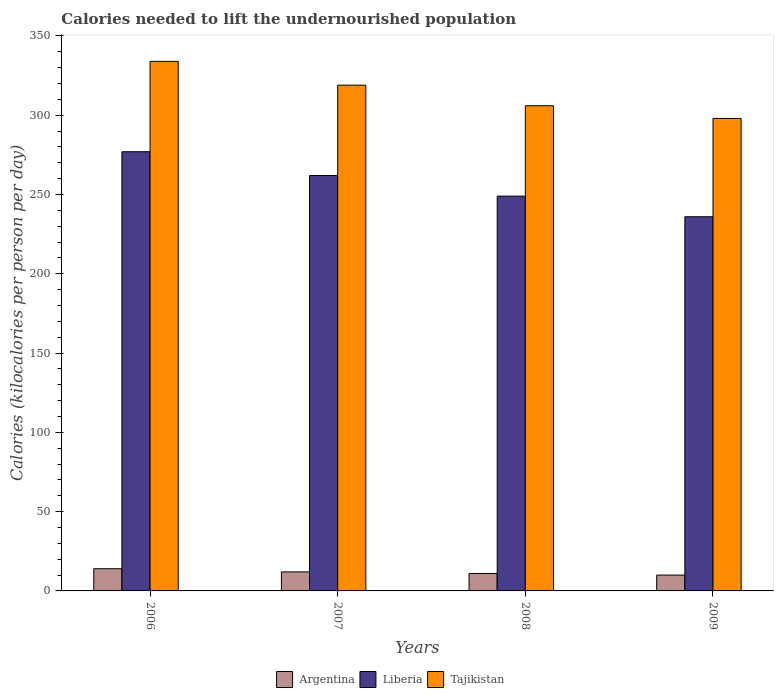How many different coloured bars are there?
Keep it short and to the point. 3. How many groups of bars are there?
Your answer should be compact. 4. Are the number of bars per tick equal to the number of legend labels?
Make the answer very short. Yes. Are the number of bars on each tick of the X-axis equal?
Offer a very short reply. Yes. How many bars are there on the 3rd tick from the left?
Give a very brief answer. 3. How many bars are there on the 4th tick from the right?
Provide a short and direct response. 3. What is the label of the 2nd group of bars from the left?
Keep it short and to the point. 2007. In how many cases, is the number of bars for a given year not equal to the number of legend labels?
Ensure brevity in your answer.  0. What is the total calories needed to lift the undernourished population in Liberia in 2008?
Your answer should be compact. 249. Across all years, what is the maximum total calories needed to lift the undernourished population in Tajikistan?
Offer a very short reply. 334. Across all years, what is the minimum total calories needed to lift the undernourished population in Argentina?
Make the answer very short. 10. In which year was the total calories needed to lift the undernourished population in Tajikistan minimum?
Your response must be concise. 2009. What is the total total calories needed to lift the undernourished population in Liberia in the graph?
Offer a very short reply. 1024. What is the difference between the total calories needed to lift the undernourished population in Argentina in 2006 and that in 2009?
Provide a succinct answer. 4. What is the difference between the total calories needed to lift the undernourished population in Argentina in 2007 and the total calories needed to lift the undernourished population in Liberia in 2008?
Ensure brevity in your answer.  -237. What is the average total calories needed to lift the undernourished population in Argentina per year?
Your response must be concise. 11.75. In the year 2008, what is the difference between the total calories needed to lift the undernourished population in Argentina and total calories needed to lift the undernourished population in Tajikistan?
Your answer should be compact. -295. In how many years, is the total calories needed to lift the undernourished population in Argentina greater than 140 kilocalories?
Make the answer very short. 0. What is the ratio of the total calories needed to lift the undernourished population in Argentina in 2006 to that in 2009?
Provide a short and direct response. 1.4. Is the total calories needed to lift the undernourished population in Tajikistan in 2006 less than that in 2007?
Your answer should be very brief. No. What is the difference between the highest and the lowest total calories needed to lift the undernourished population in Liberia?
Make the answer very short. 41. In how many years, is the total calories needed to lift the undernourished population in Argentina greater than the average total calories needed to lift the undernourished population in Argentina taken over all years?
Offer a terse response. 2. What does the 1st bar from the left in 2007 represents?
Ensure brevity in your answer.  Argentina. What does the 2nd bar from the right in 2009 represents?
Offer a very short reply. Liberia. Are all the bars in the graph horizontal?
Your answer should be very brief. No. What is the difference between two consecutive major ticks on the Y-axis?
Provide a short and direct response. 50. Are the values on the major ticks of Y-axis written in scientific E-notation?
Make the answer very short. No. Does the graph contain any zero values?
Offer a terse response. No. What is the title of the graph?
Keep it short and to the point. Calories needed to lift the undernourished population. What is the label or title of the Y-axis?
Keep it short and to the point. Calories (kilocalories per person per day). What is the Calories (kilocalories per person per day) in Liberia in 2006?
Ensure brevity in your answer.  277. What is the Calories (kilocalories per person per day) of Tajikistan in 2006?
Offer a terse response. 334. What is the Calories (kilocalories per person per day) in Argentina in 2007?
Make the answer very short. 12. What is the Calories (kilocalories per person per day) of Liberia in 2007?
Your response must be concise. 262. What is the Calories (kilocalories per person per day) of Tajikistan in 2007?
Offer a terse response. 319. What is the Calories (kilocalories per person per day) of Liberia in 2008?
Ensure brevity in your answer.  249. What is the Calories (kilocalories per person per day) in Tajikistan in 2008?
Provide a succinct answer. 306. What is the Calories (kilocalories per person per day) of Liberia in 2009?
Keep it short and to the point. 236. What is the Calories (kilocalories per person per day) of Tajikistan in 2009?
Provide a short and direct response. 298. Across all years, what is the maximum Calories (kilocalories per person per day) of Liberia?
Keep it short and to the point. 277. Across all years, what is the maximum Calories (kilocalories per person per day) of Tajikistan?
Provide a short and direct response. 334. Across all years, what is the minimum Calories (kilocalories per person per day) in Liberia?
Your answer should be compact. 236. Across all years, what is the minimum Calories (kilocalories per person per day) in Tajikistan?
Your answer should be compact. 298. What is the total Calories (kilocalories per person per day) in Liberia in the graph?
Provide a short and direct response. 1024. What is the total Calories (kilocalories per person per day) of Tajikistan in the graph?
Give a very brief answer. 1257. What is the difference between the Calories (kilocalories per person per day) in Liberia in 2006 and that in 2007?
Provide a succinct answer. 15. What is the difference between the Calories (kilocalories per person per day) of Liberia in 2006 and that in 2009?
Your answer should be compact. 41. What is the difference between the Calories (kilocalories per person per day) in Tajikistan in 2006 and that in 2009?
Your answer should be very brief. 36. What is the difference between the Calories (kilocalories per person per day) of Argentina in 2007 and that in 2008?
Your answer should be very brief. 1. What is the difference between the Calories (kilocalories per person per day) in Tajikistan in 2007 and that in 2008?
Ensure brevity in your answer.  13. What is the difference between the Calories (kilocalories per person per day) of Liberia in 2007 and that in 2009?
Offer a very short reply. 26. What is the difference between the Calories (kilocalories per person per day) of Tajikistan in 2007 and that in 2009?
Provide a succinct answer. 21. What is the difference between the Calories (kilocalories per person per day) of Liberia in 2008 and that in 2009?
Provide a succinct answer. 13. What is the difference between the Calories (kilocalories per person per day) in Argentina in 2006 and the Calories (kilocalories per person per day) in Liberia in 2007?
Ensure brevity in your answer.  -248. What is the difference between the Calories (kilocalories per person per day) of Argentina in 2006 and the Calories (kilocalories per person per day) of Tajikistan in 2007?
Keep it short and to the point. -305. What is the difference between the Calories (kilocalories per person per day) in Liberia in 2006 and the Calories (kilocalories per person per day) in Tajikistan in 2007?
Make the answer very short. -42. What is the difference between the Calories (kilocalories per person per day) in Argentina in 2006 and the Calories (kilocalories per person per day) in Liberia in 2008?
Make the answer very short. -235. What is the difference between the Calories (kilocalories per person per day) of Argentina in 2006 and the Calories (kilocalories per person per day) of Tajikistan in 2008?
Make the answer very short. -292. What is the difference between the Calories (kilocalories per person per day) in Liberia in 2006 and the Calories (kilocalories per person per day) in Tajikistan in 2008?
Make the answer very short. -29. What is the difference between the Calories (kilocalories per person per day) in Argentina in 2006 and the Calories (kilocalories per person per day) in Liberia in 2009?
Provide a succinct answer. -222. What is the difference between the Calories (kilocalories per person per day) in Argentina in 2006 and the Calories (kilocalories per person per day) in Tajikistan in 2009?
Your answer should be compact. -284. What is the difference between the Calories (kilocalories per person per day) of Argentina in 2007 and the Calories (kilocalories per person per day) of Liberia in 2008?
Ensure brevity in your answer.  -237. What is the difference between the Calories (kilocalories per person per day) of Argentina in 2007 and the Calories (kilocalories per person per day) of Tajikistan in 2008?
Your answer should be compact. -294. What is the difference between the Calories (kilocalories per person per day) of Liberia in 2007 and the Calories (kilocalories per person per day) of Tajikistan in 2008?
Provide a short and direct response. -44. What is the difference between the Calories (kilocalories per person per day) of Argentina in 2007 and the Calories (kilocalories per person per day) of Liberia in 2009?
Give a very brief answer. -224. What is the difference between the Calories (kilocalories per person per day) of Argentina in 2007 and the Calories (kilocalories per person per day) of Tajikistan in 2009?
Your answer should be compact. -286. What is the difference between the Calories (kilocalories per person per day) in Liberia in 2007 and the Calories (kilocalories per person per day) in Tajikistan in 2009?
Your answer should be compact. -36. What is the difference between the Calories (kilocalories per person per day) in Argentina in 2008 and the Calories (kilocalories per person per day) in Liberia in 2009?
Give a very brief answer. -225. What is the difference between the Calories (kilocalories per person per day) in Argentina in 2008 and the Calories (kilocalories per person per day) in Tajikistan in 2009?
Offer a very short reply. -287. What is the difference between the Calories (kilocalories per person per day) of Liberia in 2008 and the Calories (kilocalories per person per day) of Tajikistan in 2009?
Give a very brief answer. -49. What is the average Calories (kilocalories per person per day) in Argentina per year?
Your response must be concise. 11.75. What is the average Calories (kilocalories per person per day) of Liberia per year?
Your response must be concise. 256. What is the average Calories (kilocalories per person per day) of Tajikistan per year?
Offer a very short reply. 314.25. In the year 2006, what is the difference between the Calories (kilocalories per person per day) of Argentina and Calories (kilocalories per person per day) of Liberia?
Offer a very short reply. -263. In the year 2006, what is the difference between the Calories (kilocalories per person per day) in Argentina and Calories (kilocalories per person per day) in Tajikistan?
Offer a very short reply. -320. In the year 2006, what is the difference between the Calories (kilocalories per person per day) in Liberia and Calories (kilocalories per person per day) in Tajikistan?
Your answer should be compact. -57. In the year 2007, what is the difference between the Calories (kilocalories per person per day) of Argentina and Calories (kilocalories per person per day) of Liberia?
Keep it short and to the point. -250. In the year 2007, what is the difference between the Calories (kilocalories per person per day) of Argentina and Calories (kilocalories per person per day) of Tajikistan?
Give a very brief answer. -307. In the year 2007, what is the difference between the Calories (kilocalories per person per day) in Liberia and Calories (kilocalories per person per day) in Tajikistan?
Provide a short and direct response. -57. In the year 2008, what is the difference between the Calories (kilocalories per person per day) in Argentina and Calories (kilocalories per person per day) in Liberia?
Your response must be concise. -238. In the year 2008, what is the difference between the Calories (kilocalories per person per day) in Argentina and Calories (kilocalories per person per day) in Tajikistan?
Make the answer very short. -295. In the year 2008, what is the difference between the Calories (kilocalories per person per day) in Liberia and Calories (kilocalories per person per day) in Tajikistan?
Your answer should be compact. -57. In the year 2009, what is the difference between the Calories (kilocalories per person per day) of Argentina and Calories (kilocalories per person per day) of Liberia?
Provide a succinct answer. -226. In the year 2009, what is the difference between the Calories (kilocalories per person per day) in Argentina and Calories (kilocalories per person per day) in Tajikistan?
Keep it short and to the point. -288. In the year 2009, what is the difference between the Calories (kilocalories per person per day) in Liberia and Calories (kilocalories per person per day) in Tajikistan?
Your answer should be compact. -62. What is the ratio of the Calories (kilocalories per person per day) of Liberia in 2006 to that in 2007?
Ensure brevity in your answer.  1.06. What is the ratio of the Calories (kilocalories per person per day) of Tajikistan in 2006 to that in 2007?
Your response must be concise. 1.05. What is the ratio of the Calories (kilocalories per person per day) of Argentina in 2006 to that in 2008?
Offer a very short reply. 1.27. What is the ratio of the Calories (kilocalories per person per day) of Liberia in 2006 to that in 2008?
Keep it short and to the point. 1.11. What is the ratio of the Calories (kilocalories per person per day) in Tajikistan in 2006 to that in 2008?
Your response must be concise. 1.09. What is the ratio of the Calories (kilocalories per person per day) in Argentina in 2006 to that in 2009?
Keep it short and to the point. 1.4. What is the ratio of the Calories (kilocalories per person per day) of Liberia in 2006 to that in 2009?
Offer a very short reply. 1.17. What is the ratio of the Calories (kilocalories per person per day) of Tajikistan in 2006 to that in 2009?
Offer a very short reply. 1.12. What is the ratio of the Calories (kilocalories per person per day) in Liberia in 2007 to that in 2008?
Make the answer very short. 1.05. What is the ratio of the Calories (kilocalories per person per day) of Tajikistan in 2007 to that in 2008?
Your answer should be very brief. 1.04. What is the ratio of the Calories (kilocalories per person per day) of Argentina in 2007 to that in 2009?
Offer a very short reply. 1.2. What is the ratio of the Calories (kilocalories per person per day) of Liberia in 2007 to that in 2009?
Your response must be concise. 1.11. What is the ratio of the Calories (kilocalories per person per day) of Tajikistan in 2007 to that in 2009?
Your response must be concise. 1.07. What is the ratio of the Calories (kilocalories per person per day) of Liberia in 2008 to that in 2009?
Keep it short and to the point. 1.06. What is the ratio of the Calories (kilocalories per person per day) of Tajikistan in 2008 to that in 2009?
Your answer should be compact. 1.03. What is the difference between the highest and the lowest Calories (kilocalories per person per day) in Argentina?
Offer a very short reply. 4. 